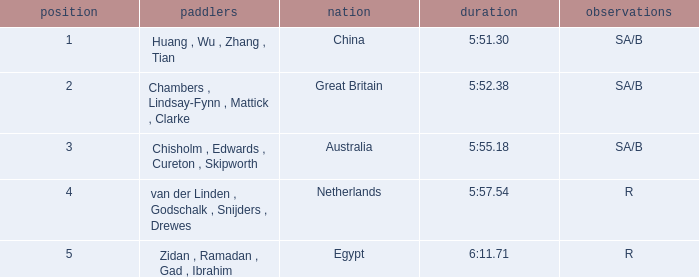What country is ranked larger than 4? Egypt. 